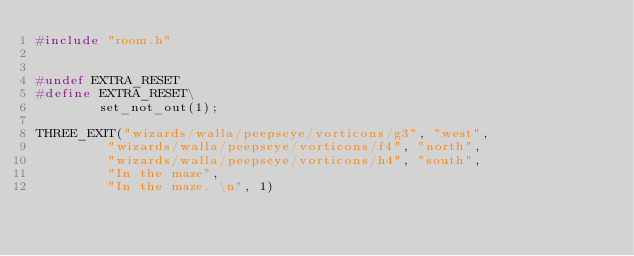<code> <loc_0><loc_0><loc_500><loc_500><_C_>#include "room.h" 
 
 
#undef EXTRA_RESET
#define EXTRA_RESET\
        set_not_out(1);
 
THREE_EXIT("wizards/walla/peepseye/vorticons/g3", "west",
         "wizards/walla/peepseye/vorticons/f4", "north",
         "wizards/walla/peepseye/vorticons/h4", "south",
         "In the maze",
         "In the maze. \n", 1)





</code> 